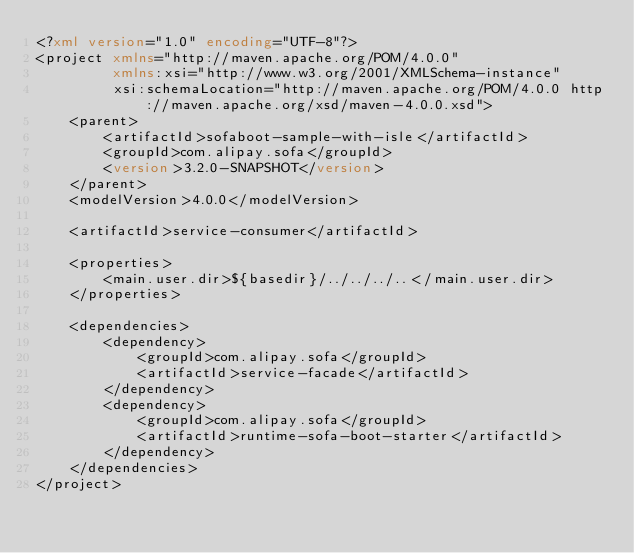<code> <loc_0><loc_0><loc_500><loc_500><_XML_><?xml version="1.0" encoding="UTF-8"?>
<project xmlns="http://maven.apache.org/POM/4.0.0"
         xmlns:xsi="http://www.w3.org/2001/XMLSchema-instance"
         xsi:schemaLocation="http://maven.apache.org/POM/4.0.0 http://maven.apache.org/xsd/maven-4.0.0.xsd">
    <parent>
        <artifactId>sofaboot-sample-with-isle</artifactId>
        <groupId>com.alipay.sofa</groupId>
        <version>3.2.0-SNAPSHOT</version>
    </parent>
    <modelVersion>4.0.0</modelVersion>

    <artifactId>service-consumer</artifactId>

    <properties>
        <main.user.dir>${basedir}/../../../..</main.user.dir>
    </properties>

    <dependencies>
        <dependency>
            <groupId>com.alipay.sofa</groupId>
            <artifactId>service-facade</artifactId>
        </dependency>
        <dependency>
            <groupId>com.alipay.sofa</groupId>
            <artifactId>runtime-sofa-boot-starter</artifactId>
        </dependency>
    </dependencies>
</project>
</code> 